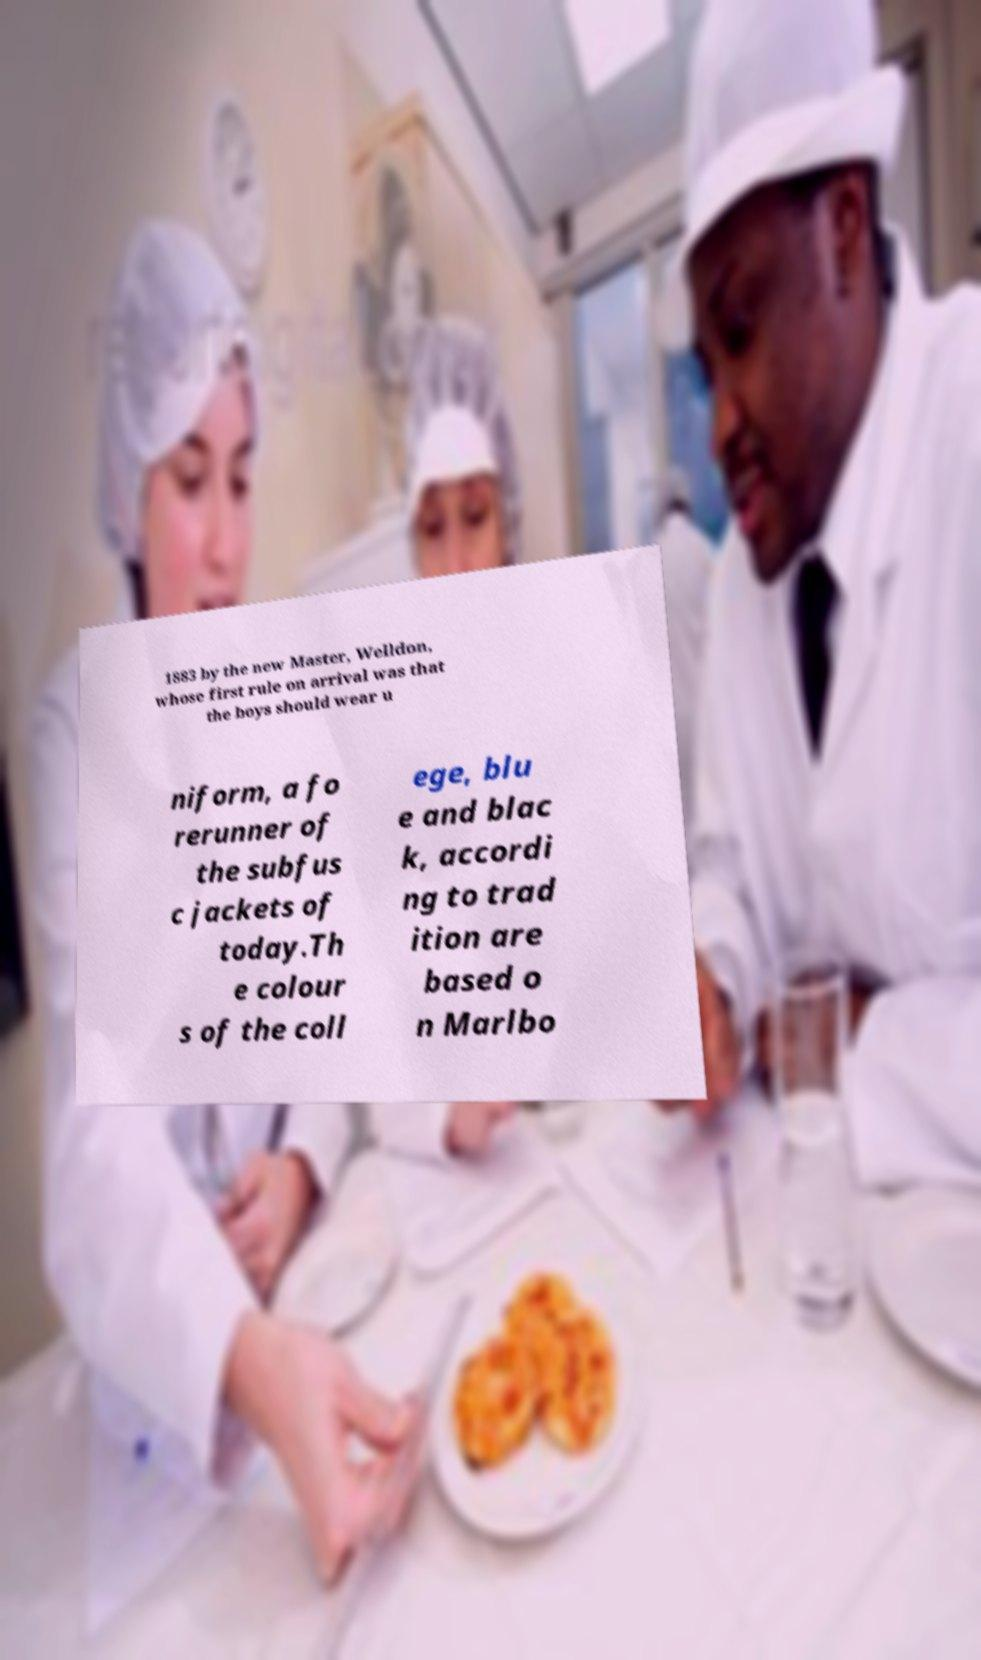Could you extract and type out the text from this image? 1883 by the new Master, Welldon, whose first rule on arrival was that the boys should wear u niform, a fo rerunner of the subfus c jackets of today.Th e colour s of the coll ege, blu e and blac k, accordi ng to trad ition are based o n Marlbo 